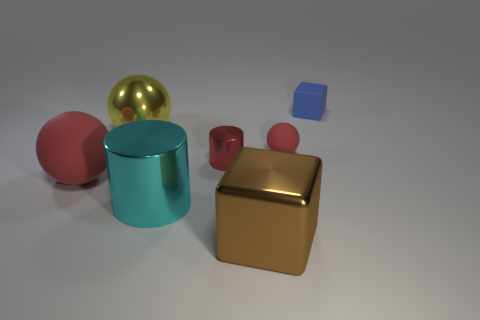How many other things are the same shape as the brown metallic thing?
Provide a short and direct response. 1. How many things are either tiny blue rubber things or tiny purple objects?
Provide a succinct answer. 1. Is the color of the small sphere the same as the tiny metallic cylinder?
Provide a succinct answer. Yes. Are there any other things that are the same size as the blue cube?
Provide a short and direct response. Yes. What shape is the red rubber thing to the right of the red ball that is to the left of the brown metal block?
Your response must be concise. Sphere. Is the number of tiny red balls less than the number of red spheres?
Your response must be concise. Yes. How big is the object that is both to the right of the cyan shiny cylinder and in front of the large red object?
Provide a succinct answer. Large. Do the cyan cylinder and the brown block have the same size?
Your answer should be compact. Yes. Does the block in front of the tiny red metallic object have the same color as the small metallic cylinder?
Offer a terse response. No. How many small red cylinders are on the left side of the brown block?
Provide a short and direct response. 1. 